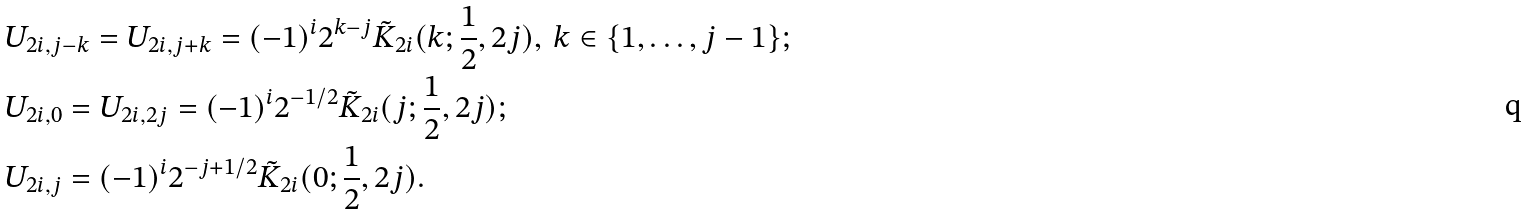Convert formula to latex. <formula><loc_0><loc_0><loc_500><loc_500>& U _ { 2 i , j - k } = U _ { 2 i , j + k } = ( - 1 ) ^ { i } 2 ^ { k - j } \tilde { K } _ { 2 i } ( k ; \frac { 1 } { 2 } , 2 j ) , \, k \in \{ 1 , \dots , j - 1 \} ; \\ & U _ { 2 i , 0 } = U _ { 2 i , 2 j } = ( - 1 ) ^ { i } 2 ^ { - 1 / 2 } \tilde { K } _ { 2 i } ( j ; \frac { 1 } { 2 } , 2 j ) ; \\ & U _ { 2 i , j } = ( - 1 ) ^ { i } 2 ^ { - j + 1 / 2 } \tilde { K } _ { 2 i } ( 0 ; \frac { 1 } { 2 } , 2 j ) .</formula> 